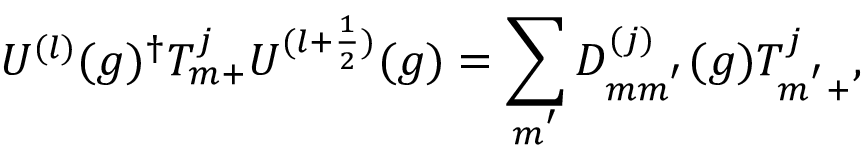<formula> <loc_0><loc_0><loc_500><loc_500>U ^ { ( l ) } ( g ) ^ { \dagger } T _ { m + } ^ { j } U ^ { ( l + \frac { 1 } { 2 } ) } ( g ) = \sum _ { m ^ { ^ { \prime } } } D _ { m m ^ { ^ { \prime } } } ^ { ( j ) } ( g ) T _ { m ^ { ^ { \prime } } + } ^ { j } ,</formula> 